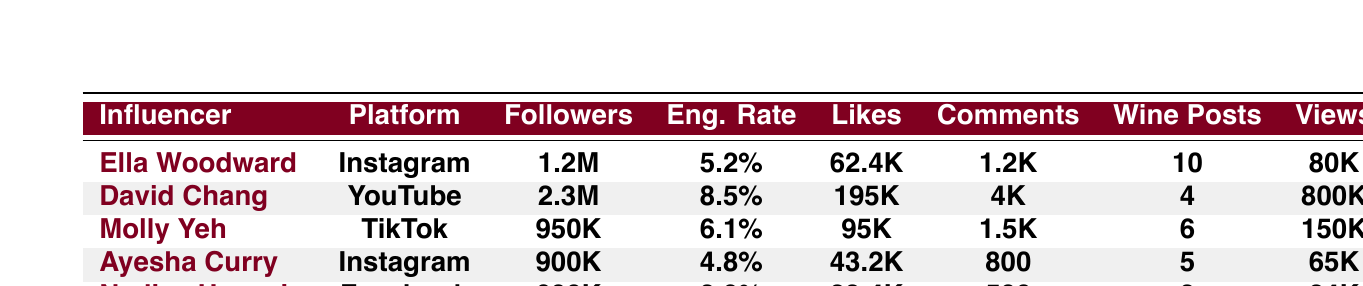What is the engagement rate of Ella Woodward? The engagement rate for Ella Woodward is directly provided in the table, listed under her details.
Answer: 5.2% Which influencer has the highest number of followers? Comparing the follower counts from the table, David Chang has 2.3 million followers, which is higher than the others.
Answer: David Chang How many posts about wine has Ayesha Curry shared? Ayesha Curry's number of posts about wine is directly found in the table as well.
Answer: 5 What are the average likes per post for Nadiya Hussain? The table provides the likes per post for Nadiya Hussain, which is listed under her entry.
Answer: 23.4K Which influencer has the lowest average engagement rate? To determine this, we compare the engagement rates of all influencers, and the lowest is Nadiya Hussain's at 3.9%.
Answer: Nadiya Hussain How many total posts about wine were shared by all influencers? By adding the number of wine posts for each influencer (10 + 4 + 6 + 5 + 3), we can find the total, which equals 28 posts.
Answer: 28 What is the difference in average views per video between David Chang and Molly Yeh? David Chang has 800,000 views per video, while Molly Yeh has 150,000 views. The difference is 800,000 - 150,000 = 650,000 views.
Answer: 650,000 Which platform has the influencer with the highest engagement rate? David Chang has the highest engagement rate of 8.5%, and he is on YouTube. Therefore, YouTube is the platform with the highest engagement rate influencer.
Answer: YouTube If Molly Yeh posted 2 more videos about wine, how many total posts about wine would she have? Currently, Molly Yeh has 6 posts about wine, and adding 2 more would make it 6 + 2 = 8 posts total.
Answer: 8 Is it true that Ella Woodward has more likes per post than Ayesha Curry? Checking the likes per post, Ella has 62.4K which is higher than Ayesha's 43.2K. So, the statement is true.
Answer: Yes 